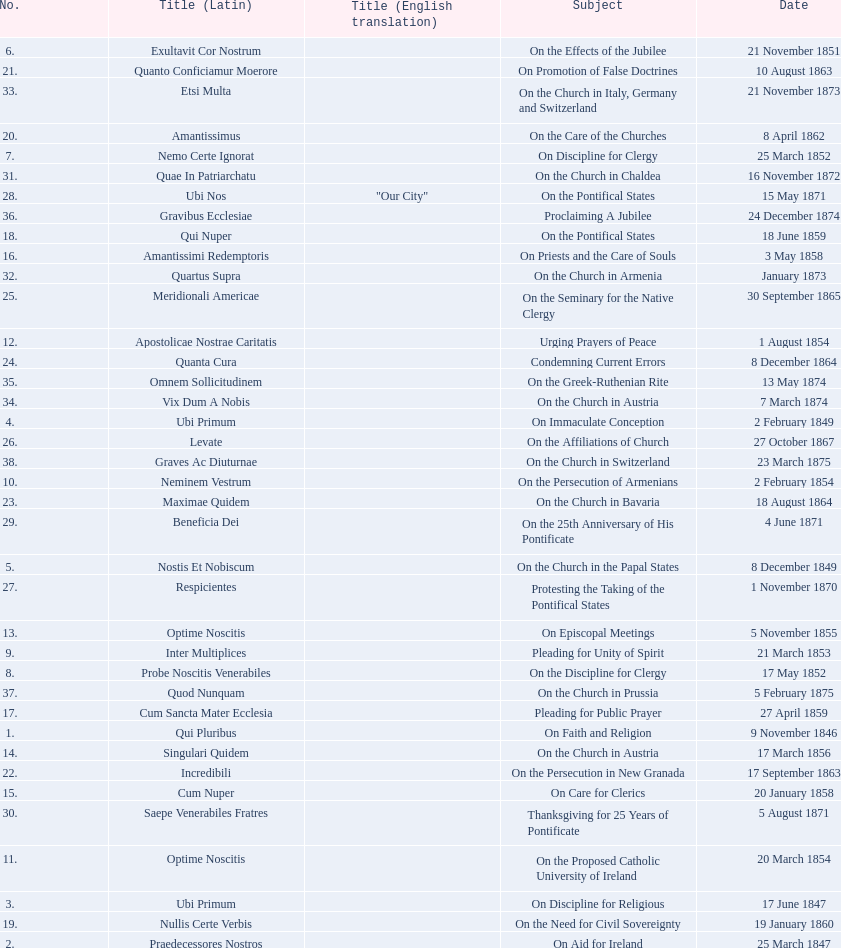What is the total number of subjects? 38. 